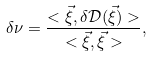Convert formula to latex. <formula><loc_0><loc_0><loc_500><loc_500>\delta \nu = \frac { < \vec { \xi } , \delta \mathcal { D } ( \vec { \xi } ) > } { < \vec { \xi } , \vec { \xi } > } ,</formula> 